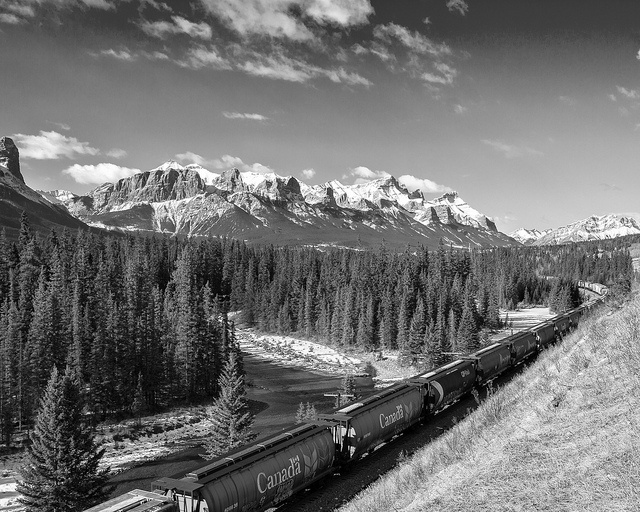Describe the objects in this image and their specific colors. I can see a train in gray, black, darkgray, and lightgray tones in this image. 